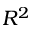<formula> <loc_0><loc_0><loc_500><loc_500>R ^ { 2 }</formula> 